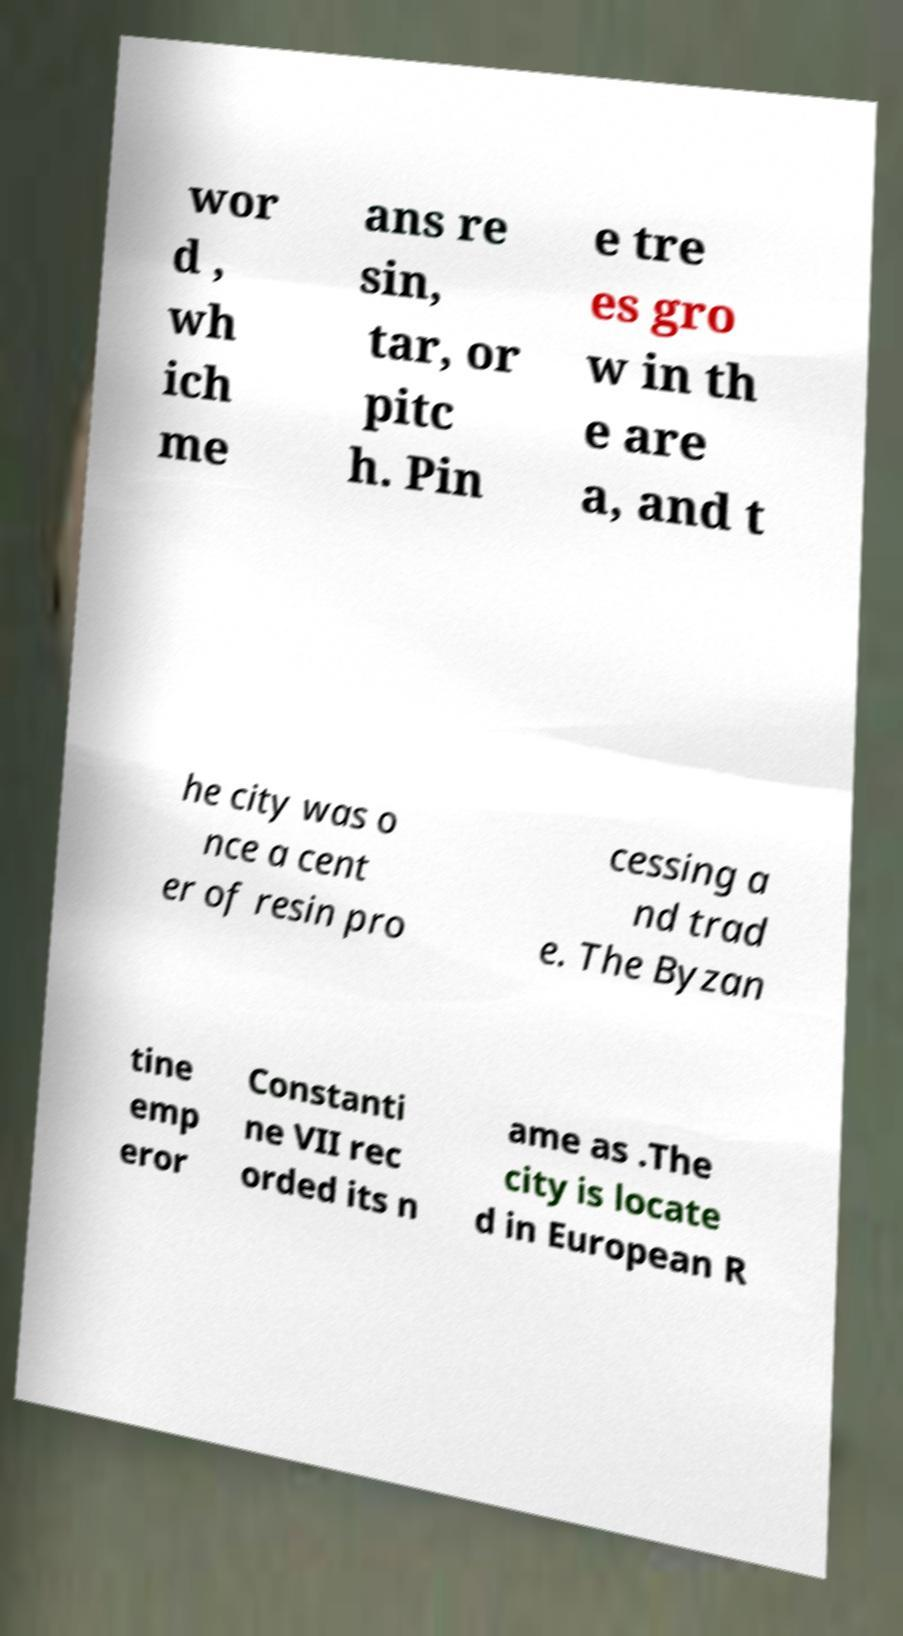For documentation purposes, I need the text within this image transcribed. Could you provide that? wor d , wh ich me ans re sin, tar, or pitc h. Pin e tre es gro w in th e are a, and t he city was o nce a cent er of resin pro cessing a nd trad e. The Byzan tine emp eror Constanti ne VII rec orded its n ame as .The city is locate d in European R 